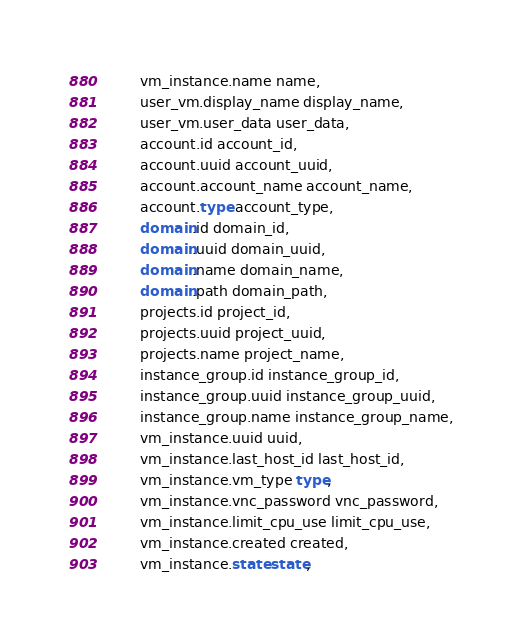<code> <loc_0><loc_0><loc_500><loc_500><_SQL_>        vm_instance.name name,
        user_vm.display_name display_name,
        user_vm.user_data user_data,
        account.id account_id,
        account.uuid account_uuid,
        account.account_name account_name,
        account.type account_type,
        domain.id domain_id,
        domain.uuid domain_uuid,
        domain.name domain_name,
        domain.path domain_path,
        projects.id project_id,
        projects.uuid project_uuid,
        projects.name project_name,
        instance_group.id instance_group_id,
        instance_group.uuid instance_group_uuid,
        instance_group.name instance_group_name,
        vm_instance.uuid uuid,
        vm_instance.last_host_id last_host_id,
        vm_instance.vm_type type,
        vm_instance.vnc_password vnc_password,
        vm_instance.limit_cpu_use limit_cpu_use,
        vm_instance.created created,
        vm_instance.state state,</code> 